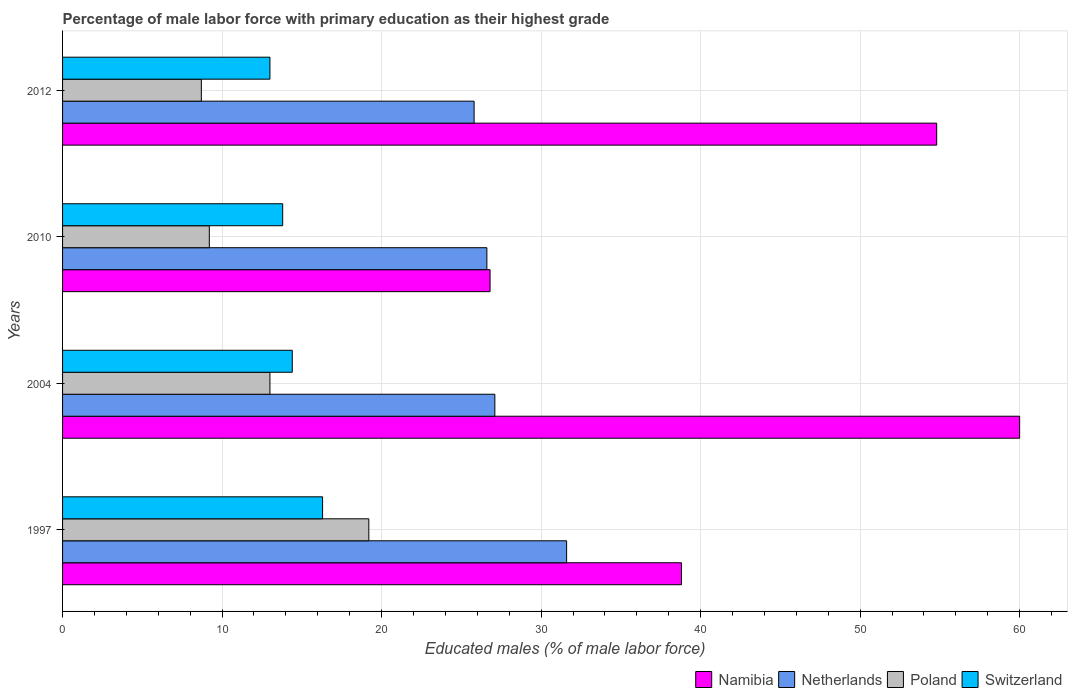How many different coloured bars are there?
Your answer should be very brief. 4. Are the number of bars on each tick of the Y-axis equal?
Keep it short and to the point. Yes. What is the label of the 3rd group of bars from the top?
Your answer should be very brief. 2004. In how many cases, is the number of bars for a given year not equal to the number of legend labels?
Your answer should be very brief. 0. What is the percentage of male labor force with primary education in Netherlands in 2004?
Make the answer very short. 27.1. Across all years, what is the minimum percentage of male labor force with primary education in Netherlands?
Provide a succinct answer. 25.8. What is the total percentage of male labor force with primary education in Namibia in the graph?
Your answer should be compact. 180.4. What is the difference between the percentage of male labor force with primary education in Poland in 2004 and that in 2012?
Make the answer very short. 4.3. What is the difference between the percentage of male labor force with primary education in Switzerland in 2004 and the percentage of male labor force with primary education in Namibia in 2012?
Keep it short and to the point. -40.4. What is the average percentage of male labor force with primary education in Netherlands per year?
Your response must be concise. 27.78. In the year 2012, what is the difference between the percentage of male labor force with primary education in Netherlands and percentage of male labor force with primary education in Poland?
Provide a short and direct response. 17.1. In how many years, is the percentage of male labor force with primary education in Poland greater than 50 %?
Ensure brevity in your answer.  0. What is the ratio of the percentage of male labor force with primary education in Netherlands in 2004 to that in 2010?
Provide a short and direct response. 1.02. Is the percentage of male labor force with primary education in Netherlands in 2010 less than that in 2012?
Your response must be concise. No. What is the difference between the highest and the second highest percentage of male labor force with primary education in Switzerland?
Provide a succinct answer. 1.9. What is the difference between the highest and the lowest percentage of male labor force with primary education in Switzerland?
Ensure brevity in your answer.  3.3. In how many years, is the percentage of male labor force with primary education in Netherlands greater than the average percentage of male labor force with primary education in Netherlands taken over all years?
Your response must be concise. 1. Is it the case that in every year, the sum of the percentage of male labor force with primary education in Netherlands and percentage of male labor force with primary education in Switzerland is greater than the sum of percentage of male labor force with primary education in Namibia and percentage of male labor force with primary education in Poland?
Your answer should be very brief. Yes. What does the 4th bar from the top in 1997 represents?
Your answer should be very brief. Namibia. What does the 1st bar from the bottom in 2010 represents?
Keep it short and to the point. Namibia. How many bars are there?
Offer a terse response. 16. Are all the bars in the graph horizontal?
Give a very brief answer. Yes. How many years are there in the graph?
Ensure brevity in your answer.  4. Does the graph contain grids?
Your answer should be very brief. Yes. Where does the legend appear in the graph?
Make the answer very short. Bottom right. How many legend labels are there?
Provide a short and direct response. 4. What is the title of the graph?
Offer a very short reply. Percentage of male labor force with primary education as their highest grade. What is the label or title of the X-axis?
Your response must be concise. Educated males (% of male labor force). What is the Educated males (% of male labor force) in Namibia in 1997?
Your answer should be very brief. 38.8. What is the Educated males (% of male labor force) in Netherlands in 1997?
Your response must be concise. 31.6. What is the Educated males (% of male labor force) of Poland in 1997?
Your answer should be compact. 19.2. What is the Educated males (% of male labor force) in Switzerland in 1997?
Ensure brevity in your answer.  16.3. What is the Educated males (% of male labor force) in Namibia in 2004?
Offer a terse response. 60. What is the Educated males (% of male labor force) in Netherlands in 2004?
Give a very brief answer. 27.1. What is the Educated males (% of male labor force) of Switzerland in 2004?
Provide a succinct answer. 14.4. What is the Educated males (% of male labor force) of Namibia in 2010?
Provide a succinct answer. 26.8. What is the Educated males (% of male labor force) of Netherlands in 2010?
Make the answer very short. 26.6. What is the Educated males (% of male labor force) in Poland in 2010?
Offer a terse response. 9.2. What is the Educated males (% of male labor force) in Switzerland in 2010?
Ensure brevity in your answer.  13.8. What is the Educated males (% of male labor force) of Namibia in 2012?
Give a very brief answer. 54.8. What is the Educated males (% of male labor force) in Netherlands in 2012?
Keep it short and to the point. 25.8. What is the Educated males (% of male labor force) of Poland in 2012?
Ensure brevity in your answer.  8.7. What is the Educated males (% of male labor force) in Switzerland in 2012?
Give a very brief answer. 13. Across all years, what is the maximum Educated males (% of male labor force) in Namibia?
Ensure brevity in your answer.  60. Across all years, what is the maximum Educated males (% of male labor force) of Netherlands?
Make the answer very short. 31.6. Across all years, what is the maximum Educated males (% of male labor force) of Poland?
Your response must be concise. 19.2. Across all years, what is the maximum Educated males (% of male labor force) of Switzerland?
Your answer should be compact. 16.3. Across all years, what is the minimum Educated males (% of male labor force) of Namibia?
Provide a short and direct response. 26.8. Across all years, what is the minimum Educated males (% of male labor force) of Netherlands?
Ensure brevity in your answer.  25.8. Across all years, what is the minimum Educated males (% of male labor force) of Poland?
Your answer should be very brief. 8.7. Across all years, what is the minimum Educated males (% of male labor force) in Switzerland?
Ensure brevity in your answer.  13. What is the total Educated males (% of male labor force) in Namibia in the graph?
Offer a terse response. 180.4. What is the total Educated males (% of male labor force) of Netherlands in the graph?
Your response must be concise. 111.1. What is the total Educated males (% of male labor force) of Poland in the graph?
Keep it short and to the point. 50.1. What is the total Educated males (% of male labor force) of Switzerland in the graph?
Your response must be concise. 57.5. What is the difference between the Educated males (% of male labor force) of Namibia in 1997 and that in 2004?
Your answer should be very brief. -21.2. What is the difference between the Educated males (% of male labor force) of Namibia in 1997 and that in 2010?
Give a very brief answer. 12. What is the difference between the Educated males (% of male labor force) of Poland in 1997 and that in 2010?
Your answer should be very brief. 10. What is the difference between the Educated males (% of male labor force) in Namibia in 1997 and that in 2012?
Offer a very short reply. -16. What is the difference between the Educated males (% of male labor force) of Netherlands in 1997 and that in 2012?
Offer a very short reply. 5.8. What is the difference between the Educated males (% of male labor force) in Switzerland in 1997 and that in 2012?
Offer a very short reply. 3.3. What is the difference between the Educated males (% of male labor force) in Namibia in 2004 and that in 2010?
Ensure brevity in your answer.  33.2. What is the difference between the Educated males (% of male labor force) in Netherlands in 2004 and that in 2010?
Keep it short and to the point. 0.5. What is the difference between the Educated males (% of male labor force) in Namibia in 2004 and that in 2012?
Provide a succinct answer. 5.2. What is the difference between the Educated males (% of male labor force) of Poland in 2004 and that in 2012?
Keep it short and to the point. 4.3. What is the difference between the Educated males (% of male labor force) of Namibia in 2010 and that in 2012?
Offer a very short reply. -28. What is the difference between the Educated males (% of male labor force) of Poland in 2010 and that in 2012?
Ensure brevity in your answer.  0.5. What is the difference between the Educated males (% of male labor force) in Switzerland in 2010 and that in 2012?
Give a very brief answer. 0.8. What is the difference between the Educated males (% of male labor force) in Namibia in 1997 and the Educated males (% of male labor force) in Netherlands in 2004?
Offer a very short reply. 11.7. What is the difference between the Educated males (% of male labor force) in Namibia in 1997 and the Educated males (% of male labor force) in Poland in 2004?
Give a very brief answer. 25.8. What is the difference between the Educated males (% of male labor force) in Namibia in 1997 and the Educated males (% of male labor force) in Switzerland in 2004?
Keep it short and to the point. 24.4. What is the difference between the Educated males (% of male labor force) in Netherlands in 1997 and the Educated males (% of male labor force) in Poland in 2004?
Make the answer very short. 18.6. What is the difference between the Educated males (% of male labor force) in Netherlands in 1997 and the Educated males (% of male labor force) in Switzerland in 2004?
Offer a terse response. 17.2. What is the difference between the Educated males (% of male labor force) in Poland in 1997 and the Educated males (% of male labor force) in Switzerland in 2004?
Your answer should be very brief. 4.8. What is the difference between the Educated males (% of male labor force) in Namibia in 1997 and the Educated males (% of male labor force) in Poland in 2010?
Provide a succinct answer. 29.6. What is the difference between the Educated males (% of male labor force) of Namibia in 1997 and the Educated males (% of male labor force) of Switzerland in 2010?
Your answer should be very brief. 25. What is the difference between the Educated males (% of male labor force) in Netherlands in 1997 and the Educated males (% of male labor force) in Poland in 2010?
Offer a terse response. 22.4. What is the difference between the Educated males (% of male labor force) in Netherlands in 1997 and the Educated males (% of male labor force) in Switzerland in 2010?
Your answer should be compact. 17.8. What is the difference between the Educated males (% of male labor force) in Poland in 1997 and the Educated males (% of male labor force) in Switzerland in 2010?
Provide a succinct answer. 5.4. What is the difference between the Educated males (% of male labor force) of Namibia in 1997 and the Educated males (% of male labor force) of Poland in 2012?
Offer a terse response. 30.1. What is the difference between the Educated males (% of male labor force) of Namibia in 1997 and the Educated males (% of male labor force) of Switzerland in 2012?
Your answer should be very brief. 25.8. What is the difference between the Educated males (% of male labor force) of Netherlands in 1997 and the Educated males (% of male labor force) of Poland in 2012?
Your response must be concise. 22.9. What is the difference between the Educated males (% of male labor force) in Poland in 1997 and the Educated males (% of male labor force) in Switzerland in 2012?
Give a very brief answer. 6.2. What is the difference between the Educated males (% of male labor force) in Namibia in 2004 and the Educated males (% of male labor force) in Netherlands in 2010?
Your response must be concise. 33.4. What is the difference between the Educated males (% of male labor force) in Namibia in 2004 and the Educated males (% of male labor force) in Poland in 2010?
Offer a very short reply. 50.8. What is the difference between the Educated males (% of male labor force) in Namibia in 2004 and the Educated males (% of male labor force) in Switzerland in 2010?
Offer a very short reply. 46.2. What is the difference between the Educated males (% of male labor force) in Netherlands in 2004 and the Educated males (% of male labor force) in Poland in 2010?
Provide a succinct answer. 17.9. What is the difference between the Educated males (% of male labor force) of Netherlands in 2004 and the Educated males (% of male labor force) of Switzerland in 2010?
Provide a succinct answer. 13.3. What is the difference between the Educated males (% of male labor force) of Namibia in 2004 and the Educated males (% of male labor force) of Netherlands in 2012?
Ensure brevity in your answer.  34.2. What is the difference between the Educated males (% of male labor force) of Namibia in 2004 and the Educated males (% of male labor force) of Poland in 2012?
Your answer should be compact. 51.3. What is the difference between the Educated males (% of male labor force) of Netherlands in 2004 and the Educated males (% of male labor force) of Poland in 2012?
Provide a short and direct response. 18.4. What is the difference between the Educated males (% of male labor force) of Netherlands in 2004 and the Educated males (% of male labor force) of Switzerland in 2012?
Make the answer very short. 14.1. What is the difference between the Educated males (% of male labor force) of Namibia in 2010 and the Educated males (% of male labor force) of Poland in 2012?
Give a very brief answer. 18.1. What is the difference between the Educated males (% of male labor force) of Netherlands in 2010 and the Educated males (% of male labor force) of Poland in 2012?
Offer a terse response. 17.9. What is the difference between the Educated males (% of male labor force) of Netherlands in 2010 and the Educated males (% of male labor force) of Switzerland in 2012?
Provide a short and direct response. 13.6. What is the average Educated males (% of male labor force) in Namibia per year?
Your answer should be very brief. 45.1. What is the average Educated males (% of male labor force) in Netherlands per year?
Ensure brevity in your answer.  27.77. What is the average Educated males (% of male labor force) in Poland per year?
Provide a short and direct response. 12.53. What is the average Educated males (% of male labor force) in Switzerland per year?
Provide a short and direct response. 14.38. In the year 1997, what is the difference between the Educated males (% of male labor force) in Namibia and Educated males (% of male labor force) in Netherlands?
Offer a very short reply. 7.2. In the year 1997, what is the difference between the Educated males (% of male labor force) of Namibia and Educated males (% of male labor force) of Poland?
Make the answer very short. 19.6. In the year 1997, what is the difference between the Educated males (% of male labor force) of Netherlands and Educated males (% of male labor force) of Switzerland?
Offer a terse response. 15.3. In the year 1997, what is the difference between the Educated males (% of male labor force) in Poland and Educated males (% of male labor force) in Switzerland?
Keep it short and to the point. 2.9. In the year 2004, what is the difference between the Educated males (% of male labor force) of Namibia and Educated males (% of male labor force) of Netherlands?
Ensure brevity in your answer.  32.9. In the year 2004, what is the difference between the Educated males (% of male labor force) in Namibia and Educated males (% of male labor force) in Poland?
Keep it short and to the point. 47. In the year 2004, what is the difference between the Educated males (% of male labor force) in Namibia and Educated males (% of male labor force) in Switzerland?
Your answer should be compact. 45.6. In the year 2004, what is the difference between the Educated males (% of male labor force) in Netherlands and Educated males (% of male labor force) in Switzerland?
Your answer should be compact. 12.7. In the year 2010, what is the difference between the Educated males (% of male labor force) in Poland and Educated males (% of male labor force) in Switzerland?
Your answer should be very brief. -4.6. In the year 2012, what is the difference between the Educated males (% of male labor force) in Namibia and Educated males (% of male labor force) in Poland?
Ensure brevity in your answer.  46.1. In the year 2012, what is the difference between the Educated males (% of male labor force) in Namibia and Educated males (% of male labor force) in Switzerland?
Your response must be concise. 41.8. In the year 2012, what is the difference between the Educated males (% of male labor force) in Netherlands and Educated males (% of male labor force) in Poland?
Keep it short and to the point. 17.1. In the year 2012, what is the difference between the Educated males (% of male labor force) of Netherlands and Educated males (% of male labor force) of Switzerland?
Keep it short and to the point. 12.8. In the year 2012, what is the difference between the Educated males (% of male labor force) in Poland and Educated males (% of male labor force) in Switzerland?
Offer a very short reply. -4.3. What is the ratio of the Educated males (% of male labor force) of Namibia in 1997 to that in 2004?
Your response must be concise. 0.65. What is the ratio of the Educated males (% of male labor force) in Netherlands in 1997 to that in 2004?
Provide a succinct answer. 1.17. What is the ratio of the Educated males (% of male labor force) of Poland in 1997 to that in 2004?
Offer a terse response. 1.48. What is the ratio of the Educated males (% of male labor force) in Switzerland in 1997 to that in 2004?
Offer a very short reply. 1.13. What is the ratio of the Educated males (% of male labor force) of Namibia in 1997 to that in 2010?
Your response must be concise. 1.45. What is the ratio of the Educated males (% of male labor force) in Netherlands in 1997 to that in 2010?
Your answer should be compact. 1.19. What is the ratio of the Educated males (% of male labor force) in Poland in 1997 to that in 2010?
Your answer should be very brief. 2.09. What is the ratio of the Educated males (% of male labor force) of Switzerland in 1997 to that in 2010?
Offer a very short reply. 1.18. What is the ratio of the Educated males (% of male labor force) of Namibia in 1997 to that in 2012?
Your response must be concise. 0.71. What is the ratio of the Educated males (% of male labor force) of Netherlands in 1997 to that in 2012?
Offer a very short reply. 1.22. What is the ratio of the Educated males (% of male labor force) in Poland in 1997 to that in 2012?
Your answer should be compact. 2.21. What is the ratio of the Educated males (% of male labor force) of Switzerland in 1997 to that in 2012?
Make the answer very short. 1.25. What is the ratio of the Educated males (% of male labor force) of Namibia in 2004 to that in 2010?
Your response must be concise. 2.24. What is the ratio of the Educated males (% of male labor force) of Netherlands in 2004 to that in 2010?
Offer a terse response. 1.02. What is the ratio of the Educated males (% of male labor force) of Poland in 2004 to that in 2010?
Offer a very short reply. 1.41. What is the ratio of the Educated males (% of male labor force) in Switzerland in 2004 to that in 2010?
Keep it short and to the point. 1.04. What is the ratio of the Educated males (% of male labor force) in Namibia in 2004 to that in 2012?
Offer a terse response. 1.09. What is the ratio of the Educated males (% of male labor force) of Netherlands in 2004 to that in 2012?
Your answer should be compact. 1.05. What is the ratio of the Educated males (% of male labor force) of Poland in 2004 to that in 2012?
Keep it short and to the point. 1.49. What is the ratio of the Educated males (% of male labor force) in Switzerland in 2004 to that in 2012?
Your answer should be compact. 1.11. What is the ratio of the Educated males (% of male labor force) of Namibia in 2010 to that in 2012?
Provide a short and direct response. 0.49. What is the ratio of the Educated males (% of male labor force) in Netherlands in 2010 to that in 2012?
Your answer should be very brief. 1.03. What is the ratio of the Educated males (% of male labor force) in Poland in 2010 to that in 2012?
Make the answer very short. 1.06. What is the ratio of the Educated males (% of male labor force) in Switzerland in 2010 to that in 2012?
Keep it short and to the point. 1.06. What is the difference between the highest and the second highest Educated males (% of male labor force) of Namibia?
Offer a very short reply. 5.2. What is the difference between the highest and the second highest Educated males (% of male labor force) in Netherlands?
Give a very brief answer. 4.5. What is the difference between the highest and the second highest Educated males (% of male labor force) in Poland?
Make the answer very short. 6.2. What is the difference between the highest and the second highest Educated males (% of male labor force) in Switzerland?
Your answer should be compact. 1.9. What is the difference between the highest and the lowest Educated males (% of male labor force) of Namibia?
Your response must be concise. 33.2. What is the difference between the highest and the lowest Educated males (% of male labor force) in Poland?
Give a very brief answer. 10.5. What is the difference between the highest and the lowest Educated males (% of male labor force) in Switzerland?
Provide a short and direct response. 3.3. 